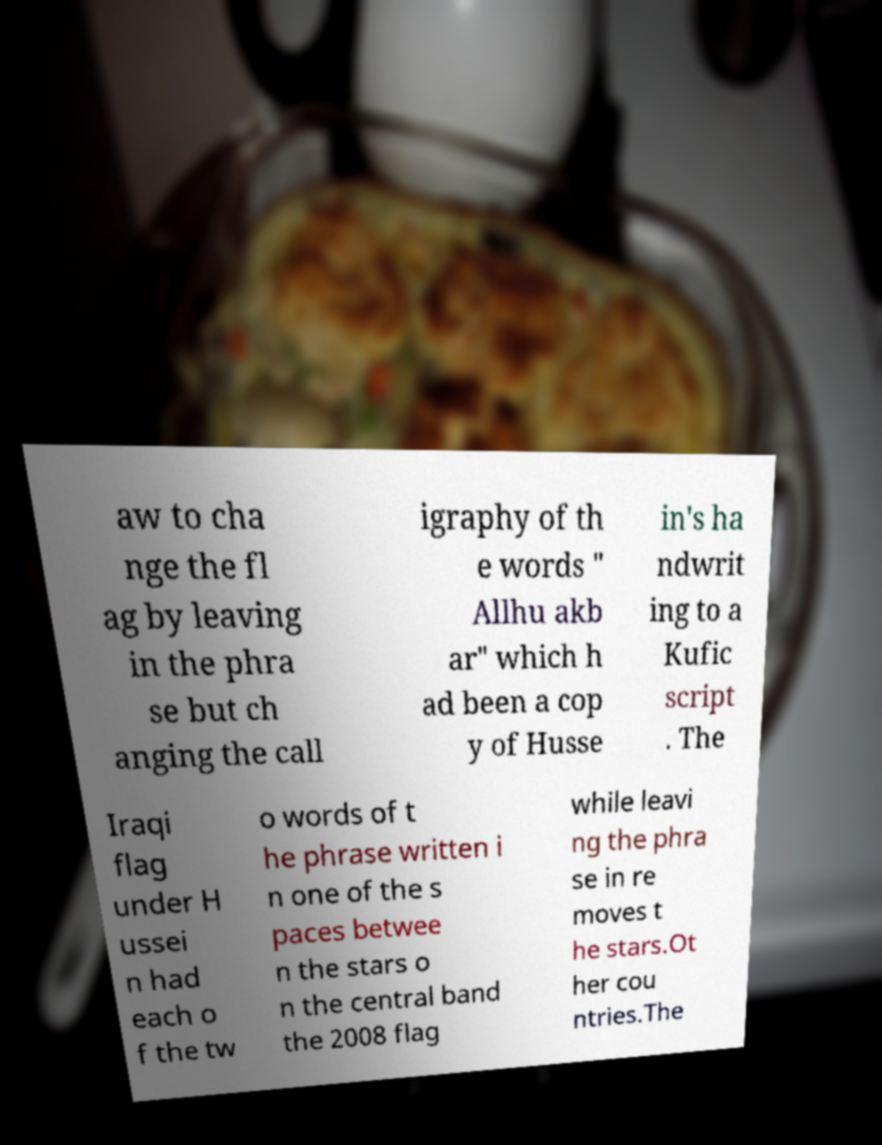Please identify and transcribe the text found in this image. aw to cha nge the fl ag by leaving in the phra se but ch anging the call igraphy of th e words " Allhu akb ar" which h ad been a cop y of Husse in's ha ndwrit ing to a Kufic script . The Iraqi flag under H ussei n had each o f the tw o words of t he phrase written i n one of the s paces betwee n the stars o n the central band the 2008 flag while leavi ng the phra se in re moves t he stars.Ot her cou ntries.The 